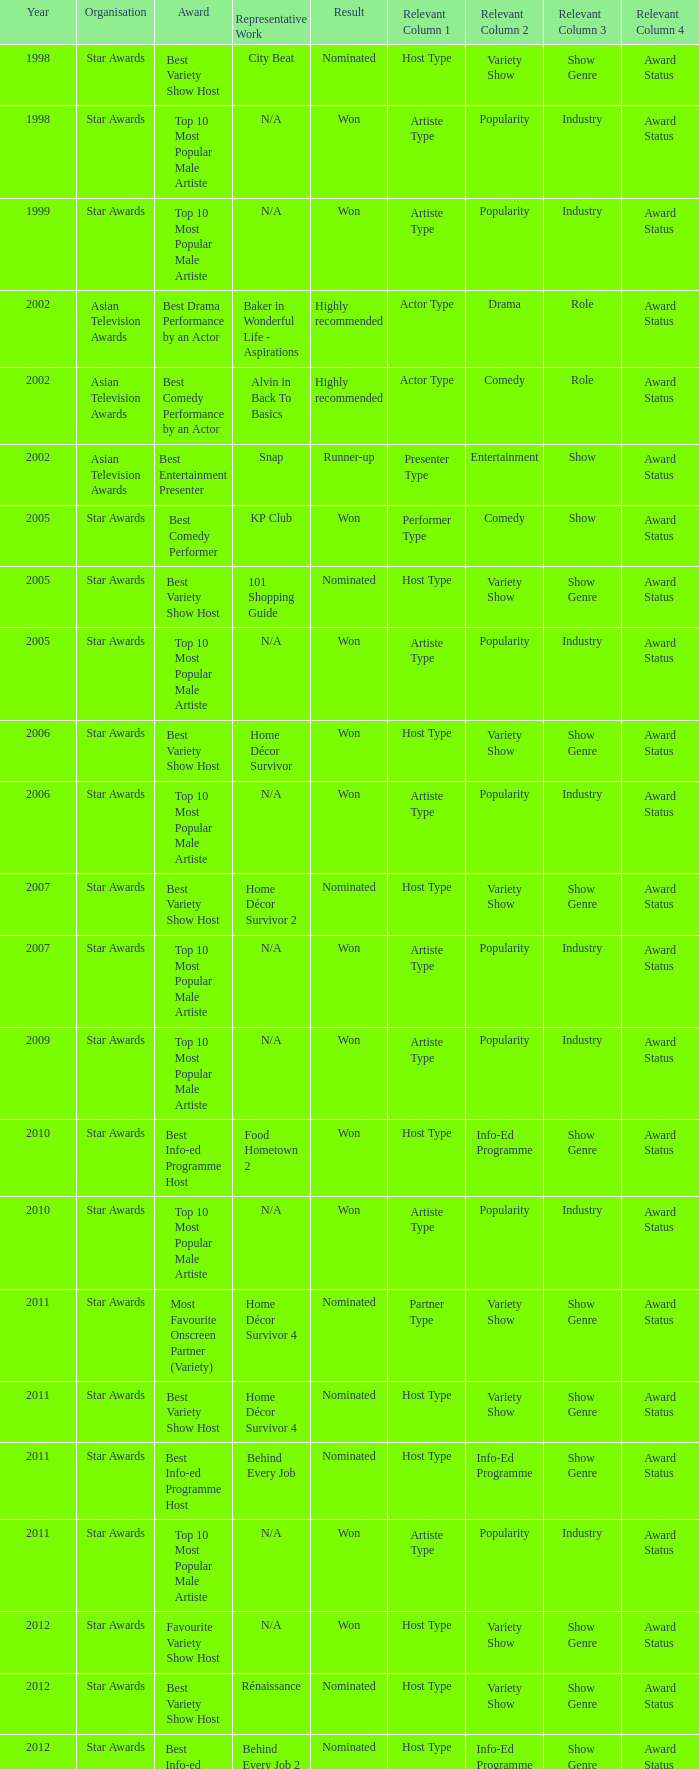What is the name of the award in a year more than 2005, and the Result of nominated? Best Variety Show Host, Most Favourite Onscreen Partner (Variety), Best Variety Show Host, Best Info-ed Programme Host, Best Variety Show Host, Best Info-ed Programme Host, Best Info-Ed Programme Host, Best Variety Show Host. 